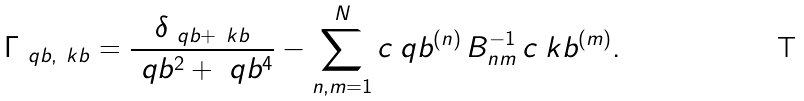<formula> <loc_0><loc_0><loc_500><loc_500>\Gamma _ { \ q b , \ k b } = \frac { \delta _ { \ q b + \ k b } } { \ q b ^ { 2 } + \ q b ^ { 4 } } - \sum _ { n , m = 1 } ^ { N } c _ { \ } q b ^ { ( n ) } \, B _ { n m } ^ { - 1 } \, c _ { \ } k b ^ { ( m ) } .</formula> 